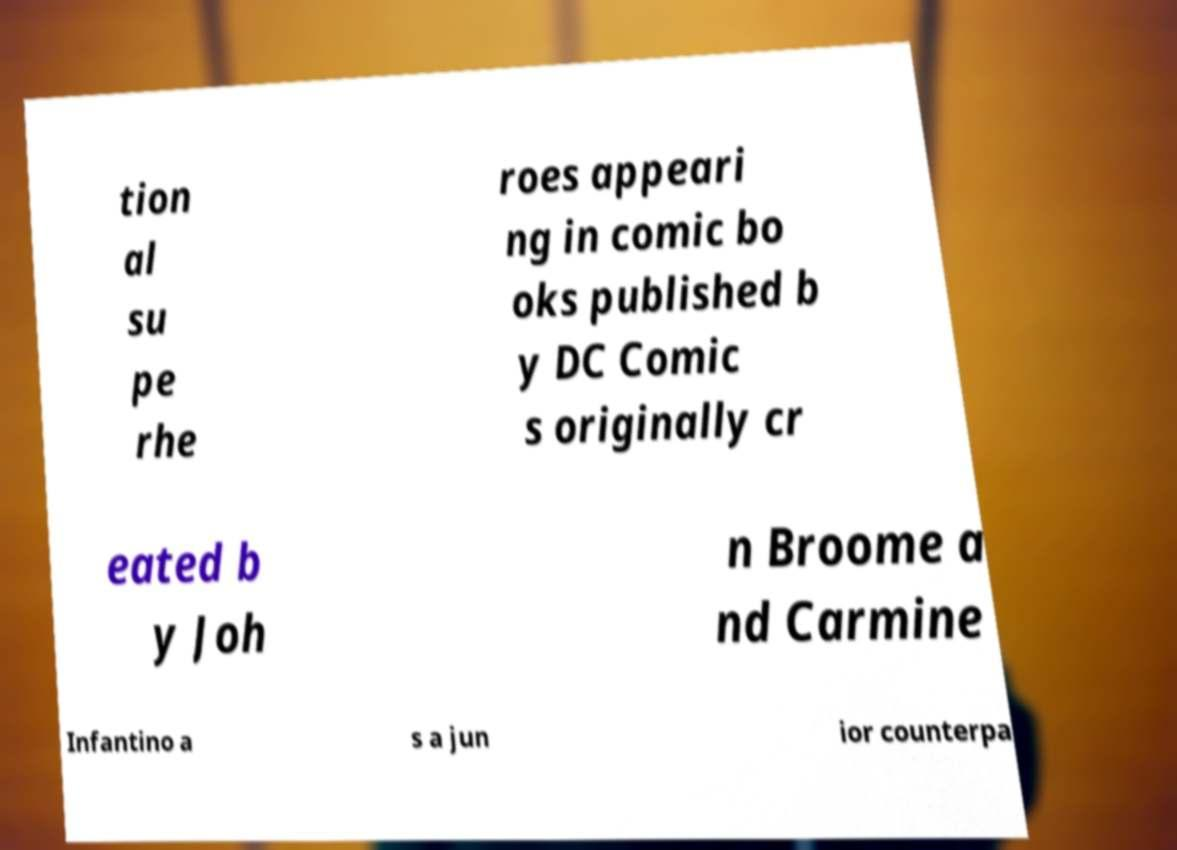There's text embedded in this image that I need extracted. Can you transcribe it verbatim? tion al su pe rhe roes appeari ng in comic bo oks published b y DC Comic s originally cr eated b y Joh n Broome a nd Carmine Infantino a s a jun ior counterpa 